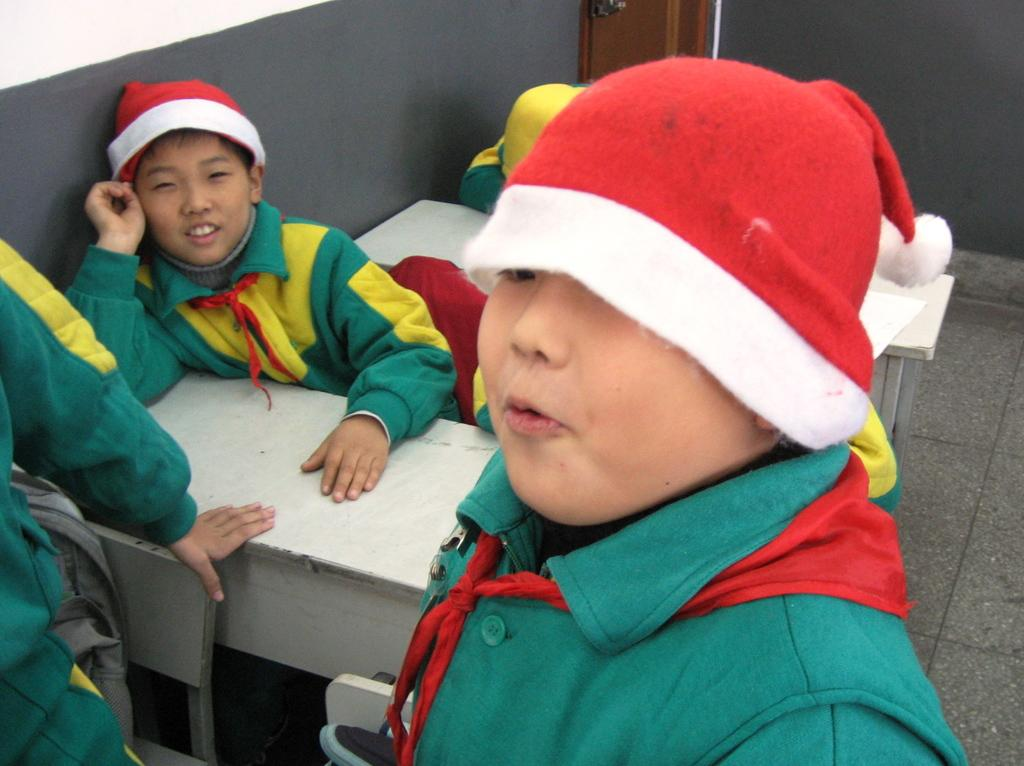Who is present in the image? There are children in the image. What are the children doing in the image? The children are sitting on benches. What are the children wearing in the image? The children are wearing Christmas hats. What can be seen behind the children in the image? There is a door, a wall, and a floor visible in the image. What type of drum is being played by the children in the image? There is no drum present in the image; the children are wearing Christmas hats and sitting on benches. What is the competition that the children are participating in within the image? There is no competition present in the image; the children are simply sitting on benches wearing Christmas hats. 